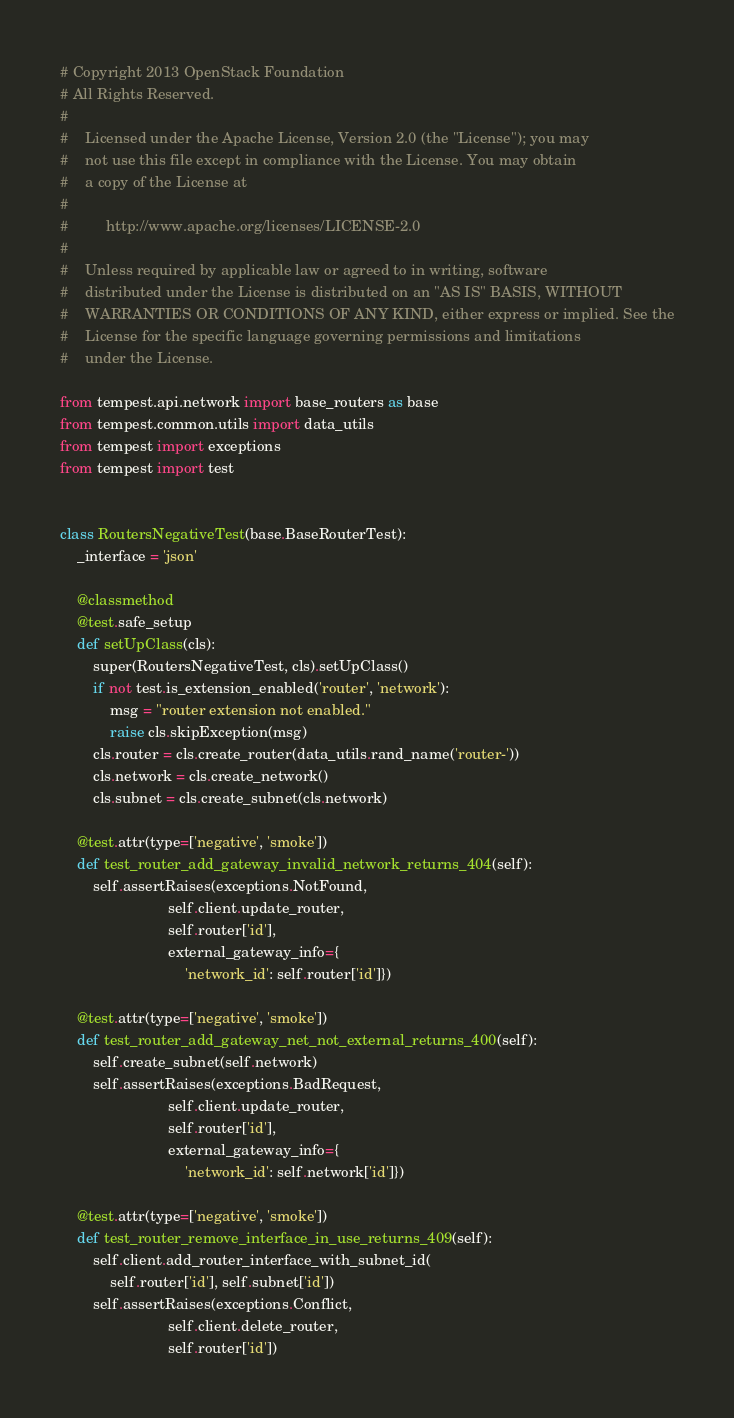<code> <loc_0><loc_0><loc_500><loc_500><_Python_># Copyright 2013 OpenStack Foundation
# All Rights Reserved.
#
#    Licensed under the Apache License, Version 2.0 (the "License"); you may
#    not use this file except in compliance with the License. You may obtain
#    a copy of the License at
#
#         http://www.apache.org/licenses/LICENSE-2.0
#
#    Unless required by applicable law or agreed to in writing, software
#    distributed under the License is distributed on an "AS IS" BASIS, WITHOUT
#    WARRANTIES OR CONDITIONS OF ANY KIND, either express or implied. See the
#    License for the specific language governing permissions and limitations
#    under the License.

from tempest.api.network import base_routers as base
from tempest.common.utils import data_utils
from tempest import exceptions
from tempest import test


class RoutersNegativeTest(base.BaseRouterTest):
    _interface = 'json'

    @classmethod
    @test.safe_setup
    def setUpClass(cls):
        super(RoutersNegativeTest, cls).setUpClass()
        if not test.is_extension_enabled('router', 'network'):
            msg = "router extension not enabled."
            raise cls.skipException(msg)
        cls.router = cls.create_router(data_utils.rand_name('router-'))
        cls.network = cls.create_network()
        cls.subnet = cls.create_subnet(cls.network)

    @test.attr(type=['negative', 'smoke'])
    def test_router_add_gateway_invalid_network_returns_404(self):
        self.assertRaises(exceptions.NotFound,
                          self.client.update_router,
                          self.router['id'],
                          external_gateway_info={
                              'network_id': self.router['id']})

    @test.attr(type=['negative', 'smoke'])
    def test_router_add_gateway_net_not_external_returns_400(self):
        self.create_subnet(self.network)
        self.assertRaises(exceptions.BadRequest,
                          self.client.update_router,
                          self.router['id'],
                          external_gateway_info={
                              'network_id': self.network['id']})

    @test.attr(type=['negative', 'smoke'])
    def test_router_remove_interface_in_use_returns_409(self):
        self.client.add_router_interface_with_subnet_id(
            self.router['id'], self.subnet['id'])
        self.assertRaises(exceptions.Conflict,
                          self.client.delete_router,
                          self.router['id'])
</code> 